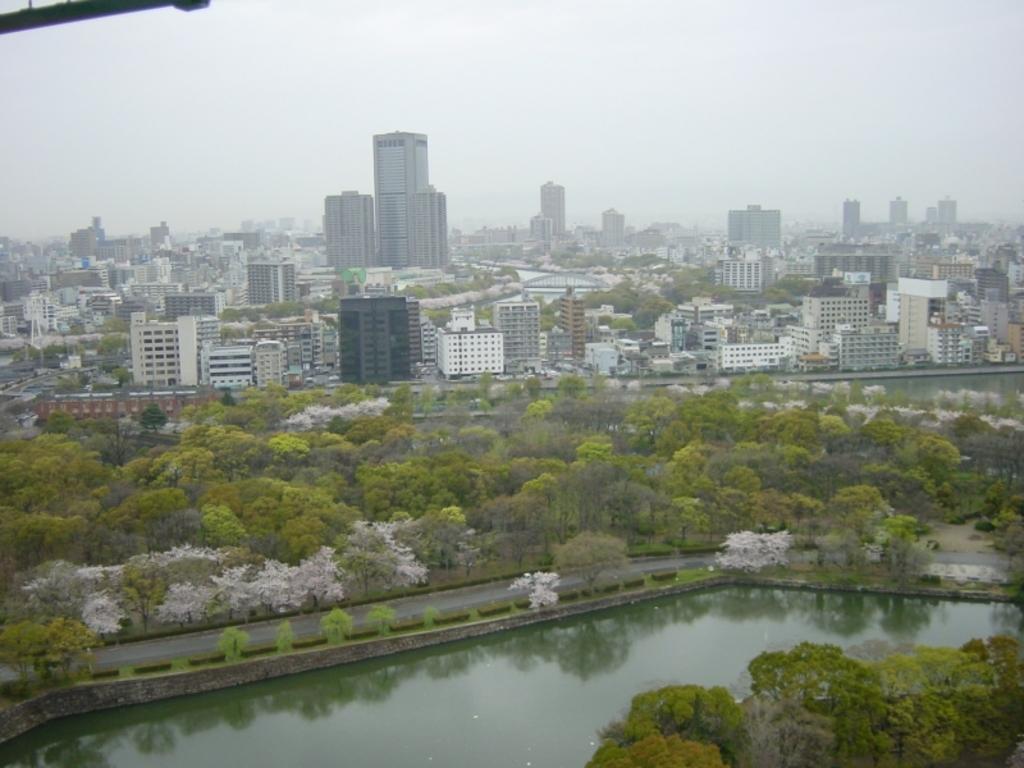Can you describe this image briefly? This is an aerial view image of a city with many buildings in the back with trees in front of it followed by a canal in the front and above its sky. 